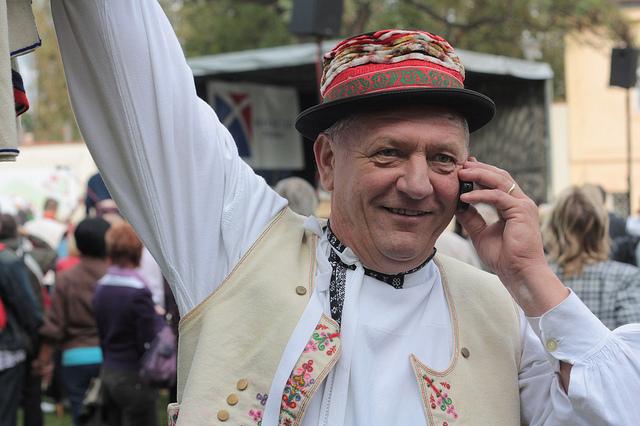Is this a normal hat?
Give a very brief answer. No. What is the pattern on the top of his hat?
Keep it brief. Lines. Is the man multi-tasking?
Short answer required. Yes. Why is his hand up in the air?
Keep it brief. Waving. What pattern is on the vests?
Short answer required. Floral. Is the man wearing a tie?
Short answer required. No. What is the man's hat made of?
Be succinct. Cloth. 